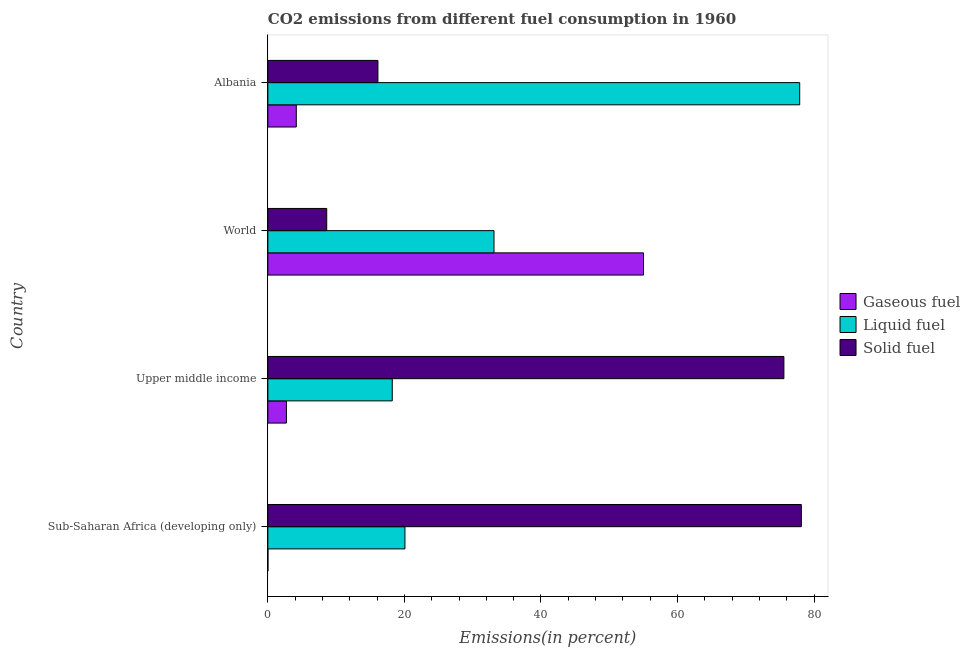How many groups of bars are there?
Make the answer very short. 4. Are the number of bars per tick equal to the number of legend labels?
Make the answer very short. Yes. How many bars are there on the 2nd tick from the top?
Provide a short and direct response. 3. What is the label of the 4th group of bars from the top?
Make the answer very short. Sub-Saharan Africa (developing only). In how many cases, is the number of bars for a given country not equal to the number of legend labels?
Give a very brief answer. 0. What is the percentage of liquid fuel emission in Sub-Saharan Africa (developing only)?
Offer a very short reply. 20.08. Across all countries, what is the maximum percentage of gaseous fuel emission?
Give a very brief answer. 55.02. Across all countries, what is the minimum percentage of liquid fuel emission?
Your answer should be compact. 18.22. In which country was the percentage of solid fuel emission maximum?
Make the answer very short. Sub-Saharan Africa (developing only). In which country was the percentage of solid fuel emission minimum?
Your response must be concise. World. What is the total percentage of liquid fuel emission in the graph?
Offer a terse response. 149.33. What is the difference between the percentage of liquid fuel emission in Albania and that in Upper middle income?
Provide a succinct answer. 59.67. What is the difference between the percentage of solid fuel emission in Sub-Saharan Africa (developing only) and the percentage of liquid fuel emission in Upper middle income?
Provide a short and direct response. 59.92. What is the average percentage of solid fuel emission per country?
Your answer should be compact. 44.62. What is the difference between the percentage of solid fuel emission and percentage of liquid fuel emission in Albania?
Ensure brevity in your answer.  -61.77. In how many countries, is the percentage of gaseous fuel emission greater than 72 %?
Provide a succinct answer. 0. What is the ratio of the percentage of liquid fuel emission in Sub-Saharan Africa (developing only) to that in Upper middle income?
Your answer should be very brief. 1.1. Is the percentage of gaseous fuel emission in Sub-Saharan Africa (developing only) less than that in World?
Your answer should be very brief. Yes. What is the difference between the highest and the second highest percentage of gaseous fuel emission?
Your answer should be compact. 50.86. What is the difference between the highest and the lowest percentage of solid fuel emission?
Keep it short and to the point. 69.52. In how many countries, is the percentage of liquid fuel emission greater than the average percentage of liquid fuel emission taken over all countries?
Ensure brevity in your answer.  1. Is the sum of the percentage of solid fuel emission in Sub-Saharan Africa (developing only) and Upper middle income greater than the maximum percentage of liquid fuel emission across all countries?
Offer a very short reply. Yes. What does the 1st bar from the top in Albania represents?
Your answer should be compact. Solid fuel. What does the 3rd bar from the bottom in Sub-Saharan Africa (developing only) represents?
Give a very brief answer. Solid fuel. Is it the case that in every country, the sum of the percentage of gaseous fuel emission and percentage of liquid fuel emission is greater than the percentage of solid fuel emission?
Make the answer very short. No. Are all the bars in the graph horizontal?
Make the answer very short. Yes. How many countries are there in the graph?
Offer a terse response. 4. What is the difference between two consecutive major ticks on the X-axis?
Keep it short and to the point. 20. Where does the legend appear in the graph?
Provide a short and direct response. Center right. How are the legend labels stacked?
Give a very brief answer. Vertical. What is the title of the graph?
Your answer should be compact. CO2 emissions from different fuel consumption in 1960. Does "Coal" appear as one of the legend labels in the graph?
Give a very brief answer. No. What is the label or title of the X-axis?
Provide a succinct answer. Emissions(in percent). What is the label or title of the Y-axis?
Offer a very short reply. Country. What is the Emissions(in percent) in Gaseous fuel in Sub-Saharan Africa (developing only)?
Your answer should be very brief. 0.01. What is the Emissions(in percent) in Liquid fuel in Sub-Saharan Africa (developing only)?
Keep it short and to the point. 20.08. What is the Emissions(in percent) of Solid fuel in Sub-Saharan Africa (developing only)?
Ensure brevity in your answer.  78.14. What is the Emissions(in percent) in Gaseous fuel in Upper middle income?
Your answer should be very brief. 2.72. What is the Emissions(in percent) of Liquid fuel in Upper middle income?
Your response must be concise. 18.22. What is the Emissions(in percent) in Solid fuel in Upper middle income?
Provide a succinct answer. 75.58. What is the Emissions(in percent) of Gaseous fuel in World?
Provide a short and direct response. 55.02. What is the Emissions(in percent) in Liquid fuel in World?
Provide a succinct answer. 33.13. What is the Emissions(in percent) of Solid fuel in World?
Offer a terse response. 8.62. What is the Emissions(in percent) in Gaseous fuel in Albania?
Provide a short and direct response. 4.17. What is the Emissions(in percent) of Liquid fuel in Albania?
Ensure brevity in your answer.  77.9. What is the Emissions(in percent) of Solid fuel in Albania?
Ensure brevity in your answer.  16.12. Across all countries, what is the maximum Emissions(in percent) of Gaseous fuel?
Your answer should be compact. 55.02. Across all countries, what is the maximum Emissions(in percent) in Liquid fuel?
Ensure brevity in your answer.  77.9. Across all countries, what is the maximum Emissions(in percent) of Solid fuel?
Offer a terse response. 78.14. Across all countries, what is the minimum Emissions(in percent) in Gaseous fuel?
Make the answer very short. 0.01. Across all countries, what is the minimum Emissions(in percent) of Liquid fuel?
Ensure brevity in your answer.  18.22. Across all countries, what is the minimum Emissions(in percent) in Solid fuel?
Make the answer very short. 8.62. What is the total Emissions(in percent) in Gaseous fuel in the graph?
Offer a very short reply. 61.93. What is the total Emissions(in percent) of Liquid fuel in the graph?
Keep it short and to the point. 149.33. What is the total Emissions(in percent) in Solid fuel in the graph?
Your answer should be compact. 178.47. What is the difference between the Emissions(in percent) of Gaseous fuel in Sub-Saharan Africa (developing only) and that in Upper middle income?
Provide a short and direct response. -2.71. What is the difference between the Emissions(in percent) in Liquid fuel in Sub-Saharan Africa (developing only) and that in Upper middle income?
Give a very brief answer. 1.86. What is the difference between the Emissions(in percent) in Solid fuel in Sub-Saharan Africa (developing only) and that in Upper middle income?
Your answer should be compact. 2.56. What is the difference between the Emissions(in percent) of Gaseous fuel in Sub-Saharan Africa (developing only) and that in World?
Your answer should be very brief. -55.01. What is the difference between the Emissions(in percent) in Liquid fuel in Sub-Saharan Africa (developing only) and that in World?
Make the answer very short. -13.05. What is the difference between the Emissions(in percent) in Solid fuel in Sub-Saharan Africa (developing only) and that in World?
Provide a short and direct response. 69.52. What is the difference between the Emissions(in percent) in Gaseous fuel in Sub-Saharan Africa (developing only) and that in Albania?
Make the answer very short. -4.15. What is the difference between the Emissions(in percent) of Liquid fuel in Sub-Saharan Africa (developing only) and that in Albania?
Ensure brevity in your answer.  -57.82. What is the difference between the Emissions(in percent) in Solid fuel in Sub-Saharan Africa (developing only) and that in Albania?
Ensure brevity in your answer.  62.02. What is the difference between the Emissions(in percent) in Gaseous fuel in Upper middle income and that in World?
Offer a very short reply. -52.3. What is the difference between the Emissions(in percent) in Liquid fuel in Upper middle income and that in World?
Your answer should be very brief. -14.9. What is the difference between the Emissions(in percent) in Solid fuel in Upper middle income and that in World?
Provide a succinct answer. 66.96. What is the difference between the Emissions(in percent) of Gaseous fuel in Upper middle income and that in Albania?
Ensure brevity in your answer.  -1.44. What is the difference between the Emissions(in percent) in Liquid fuel in Upper middle income and that in Albania?
Offer a terse response. -59.67. What is the difference between the Emissions(in percent) of Solid fuel in Upper middle income and that in Albania?
Your answer should be very brief. 59.46. What is the difference between the Emissions(in percent) in Gaseous fuel in World and that in Albania?
Provide a succinct answer. 50.86. What is the difference between the Emissions(in percent) in Liquid fuel in World and that in Albania?
Provide a succinct answer. -44.77. What is the difference between the Emissions(in percent) of Solid fuel in World and that in Albania?
Keep it short and to the point. -7.5. What is the difference between the Emissions(in percent) in Gaseous fuel in Sub-Saharan Africa (developing only) and the Emissions(in percent) in Liquid fuel in Upper middle income?
Keep it short and to the point. -18.21. What is the difference between the Emissions(in percent) in Gaseous fuel in Sub-Saharan Africa (developing only) and the Emissions(in percent) in Solid fuel in Upper middle income?
Your response must be concise. -75.57. What is the difference between the Emissions(in percent) in Liquid fuel in Sub-Saharan Africa (developing only) and the Emissions(in percent) in Solid fuel in Upper middle income?
Keep it short and to the point. -55.5. What is the difference between the Emissions(in percent) of Gaseous fuel in Sub-Saharan Africa (developing only) and the Emissions(in percent) of Liquid fuel in World?
Give a very brief answer. -33.11. What is the difference between the Emissions(in percent) of Gaseous fuel in Sub-Saharan Africa (developing only) and the Emissions(in percent) of Solid fuel in World?
Your answer should be very brief. -8.61. What is the difference between the Emissions(in percent) of Liquid fuel in Sub-Saharan Africa (developing only) and the Emissions(in percent) of Solid fuel in World?
Your answer should be very brief. 11.46. What is the difference between the Emissions(in percent) in Gaseous fuel in Sub-Saharan Africa (developing only) and the Emissions(in percent) in Liquid fuel in Albania?
Make the answer very short. -77.89. What is the difference between the Emissions(in percent) of Gaseous fuel in Sub-Saharan Africa (developing only) and the Emissions(in percent) of Solid fuel in Albania?
Offer a very short reply. -16.11. What is the difference between the Emissions(in percent) of Liquid fuel in Sub-Saharan Africa (developing only) and the Emissions(in percent) of Solid fuel in Albania?
Your response must be concise. 3.96. What is the difference between the Emissions(in percent) of Gaseous fuel in Upper middle income and the Emissions(in percent) of Liquid fuel in World?
Offer a very short reply. -30.4. What is the difference between the Emissions(in percent) of Gaseous fuel in Upper middle income and the Emissions(in percent) of Solid fuel in World?
Offer a very short reply. -5.9. What is the difference between the Emissions(in percent) of Liquid fuel in Upper middle income and the Emissions(in percent) of Solid fuel in World?
Make the answer very short. 9.6. What is the difference between the Emissions(in percent) of Gaseous fuel in Upper middle income and the Emissions(in percent) of Liquid fuel in Albania?
Provide a short and direct response. -75.18. What is the difference between the Emissions(in percent) in Gaseous fuel in Upper middle income and the Emissions(in percent) in Solid fuel in Albania?
Your answer should be compact. -13.4. What is the difference between the Emissions(in percent) of Liquid fuel in Upper middle income and the Emissions(in percent) of Solid fuel in Albania?
Your response must be concise. 2.1. What is the difference between the Emissions(in percent) of Gaseous fuel in World and the Emissions(in percent) of Liquid fuel in Albania?
Provide a short and direct response. -22.87. What is the difference between the Emissions(in percent) of Gaseous fuel in World and the Emissions(in percent) of Solid fuel in Albania?
Provide a short and direct response. 38.9. What is the difference between the Emissions(in percent) of Liquid fuel in World and the Emissions(in percent) of Solid fuel in Albania?
Provide a succinct answer. 17. What is the average Emissions(in percent) of Gaseous fuel per country?
Provide a succinct answer. 15.48. What is the average Emissions(in percent) in Liquid fuel per country?
Your response must be concise. 37.33. What is the average Emissions(in percent) of Solid fuel per country?
Your answer should be compact. 44.62. What is the difference between the Emissions(in percent) of Gaseous fuel and Emissions(in percent) of Liquid fuel in Sub-Saharan Africa (developing only)?
Make the answer very short. -20.07. What is the difference between the Emissions(in percent) of Gaseous fuel and Emissions(in percent) of Solid fuel in Sub-Saharan Africa (developing only)?
Your answer should be very brief. -78.13. What is the difference between the Emissions(in percent) in Liquid fuel and Emissions(in percent) in Solid fuel in Sub-Saharan Africa (developing only)?
Offer a very short reply. -58.06. What is the difference between the Emissions(in percent) of Gaseous fuel and Emissions(in percent) of Liquid fuel in Upper middle income?
Make the answer very short. -15.5. What is the difference between the Emissions(in percent) in Gaseous fuel and Emissions(in percent) in Solid fuel in Upper middle income?
Your answer should be very brief. -72.86. What is the difference between the Emissions(in percent) of Liquid fuel and Emissions(in percent) of Solid fuel in Upper middle income?
Provide a succinct answer. -57.36. What is the difference between the Emissions(in percent) of Gaseous fuel and Emissions(in percent) of Liquid fuel in World?
Provide a short and direct response. 21.9. What is the difference between the Emissions(in percent) of Gaseous fuel and Emissions(in percent) of Solid fuel in World?
Your answer should be compact. 46.4. What is the difference between the Emissions(in percent) in Liquid fuel and Emissions(in percent) in Solid fuel in World?
Keep it short and to the point. 24.5. What is the difference between the Emissions(in percent) of Gaseous fuel and Emissions(in percent) of Liquid fuel in Albania?
Your answer should be compact. -73.73. What is the difference between the Emissions(in percent) of Gaseous fuel and Emissions(in percent) of Solid fuel in Albania?
Give a very brief answer. -11.96. What is the difference between the Emissions(in percent) in Liquid fuel and Emissions(in percent) in Solid fuel in Albania?
Your answer should be compact. 61.78. What is the ratio of the Emissions(in percent) in Gaseous fuel in Sub-Saharan Africa (developing only) to that in Upper middle income?
Offer a terse response. 0. What is the ratio of the Emissions(in percent) in Liquid fuel in Sub-Saharan Africa (developing only) to that in Upper middle income?
Your answer should be very brief. 1.1. What is the ratio of the Emissions(in percent) in Solid fuel in Sub-Saharan Africa (developing only) to that in Upper middle income?
Provide a short and direct response. 1.03. What is the ratio of the Emissions(in percent) of Gaseous fuel in Sub-Saharan Africa (developing only) to that in World?
Your response must be concise. 0. What is the ratio of the Emissions(in percent) of Liquid fuel in Sub-Saharan Africa (developing only) to that in World?
Your response must be concise. 0.61. What is the ratio of the Emissions(in percent) of Solid fuel in Sub-Saharan Africa (developing only) to that in World?
Offer a terse response. 9.06. What is the ratio of the Emissions(in percent) of Gaseous fuel in Sub-Saharan Africa (developing only) to that in Albania?
Offer a terse response. 0. What is the ratio of the Emissions(in percent) of Liquid fuel in Sub-Saharan Africa (developing only) to that in Albania?
Your answer should be compact. 0.26. What is the ratio of the Emissions(in percent) of Solid fuel in Sub-Saharan Africa (developing only) to that in Albania?
Provide a short and direct response. 4.85. What is the ratio of the Emissions(in percent) in Gaseous fuel in Upper middle income to that in World?
Give a very brief answer. 0.05. What is the ratio of the Emissions(in percent) in Liquid fuel in Upper middle income to that in World?
Ensure brevity in your answer.  0.55. What is the ratio of the Emissions(in percent) in Solid fuel in Upper middle income to that in World?
Keep it short and to the point. 8.76. What is the ratio of the Emissions(in percent) of Gaseous fuel in Upper middle income to that in Albania?
Ensure brevity in your answer.  0.65. What is the ratio of the Emissions(in percent) of Liquid fuel in Upper middle income to that in Albania?
Provide a succinct answer. 0.23. What is the ratio of the Emissions(in percent) of Solid fuel in Upper middle income to that in Albania?
Offer a terse response. 4.69. What is the ratio of the Emissions(in percent) of Gaseous fuel in World to that in Albania?
Ensure brevity in your answer.  13.21. What is the ratio of the Emissions(in percent) of Liquid fuel in World to that in Albania?
Give a very brief answer. 0.43. What is the ratio of the Emissions(in percent) of Solid fuel in World to that in Albania?
Your response must be concise. 0.53. What is the difference between the highest and the second highest Emissions(in percent) of Gaseous fuel?
Provide a short and direct response. 50.86. What is the difference between the highest and the second highest Emissions(in percent) of Liquid fuel?
Make the answer very short. 44.77. What is the difference between the highest and the second highest Emissions(in percent) in Solid fuel?
Your answer should be compact. 2.56. What is the difference between the highest and the lowest Emissions(in percent) in Gaseous fuel?
Ensure brevity in your answer.  55.01. What is the difference between the highest and the lowest Emissions(in percent) of Liquid fuel?
Your response must be concise. 59.67. What is the difference between the highest and the lowest Emissions(in percent) in Solid fuel?
Keep it short and to the point. 69.52. 